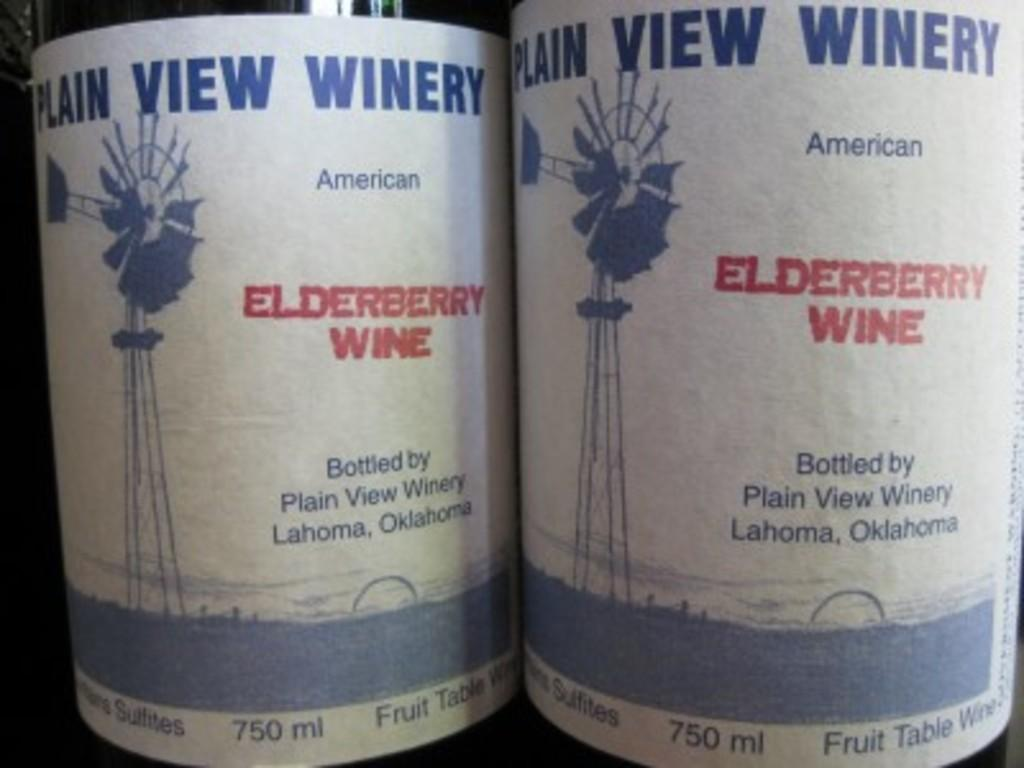How many bottles are visible in the image? There are two bottles in the image. What is unique about the bottles in the image? The bottles have stickers attached to them. What information can be found on the stickers? The stickers have writing on them. What colors are used for the writing on the stickers? The writing on the stickers is in blue and red colors. How many kittens are playing with the bell in the image? There are no kittens or bells present in the image. 